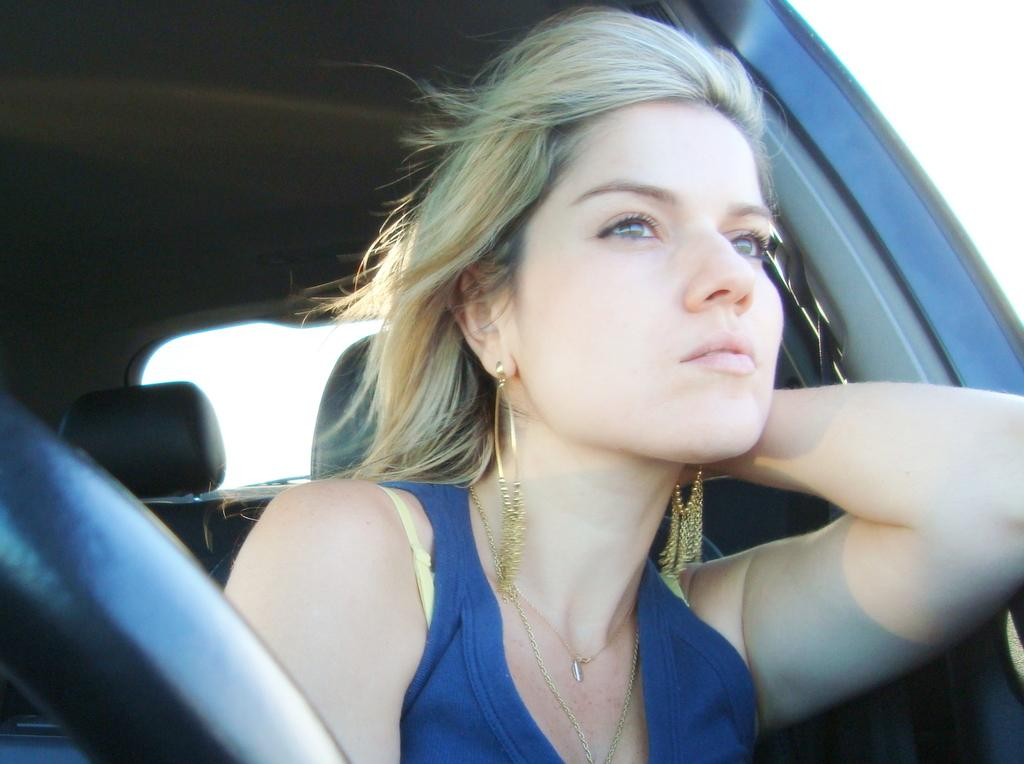Who is present in the image? There is a woman in the image. What is the woman doing in the image? The woman is sitting in a vehicle. What accessories is the woman wearing in the image? The woman is wearing earrings. What color is the dress the woman is wearing in the image? The woman is wearing a blue dress. How many bikes are parked next to the woman in the image? There are no bikes present in the image. What effect does the woman's presence have on the surrounding environment in the image? The image does not provide information about the effect of the woman's presence on the surrounding environment. 